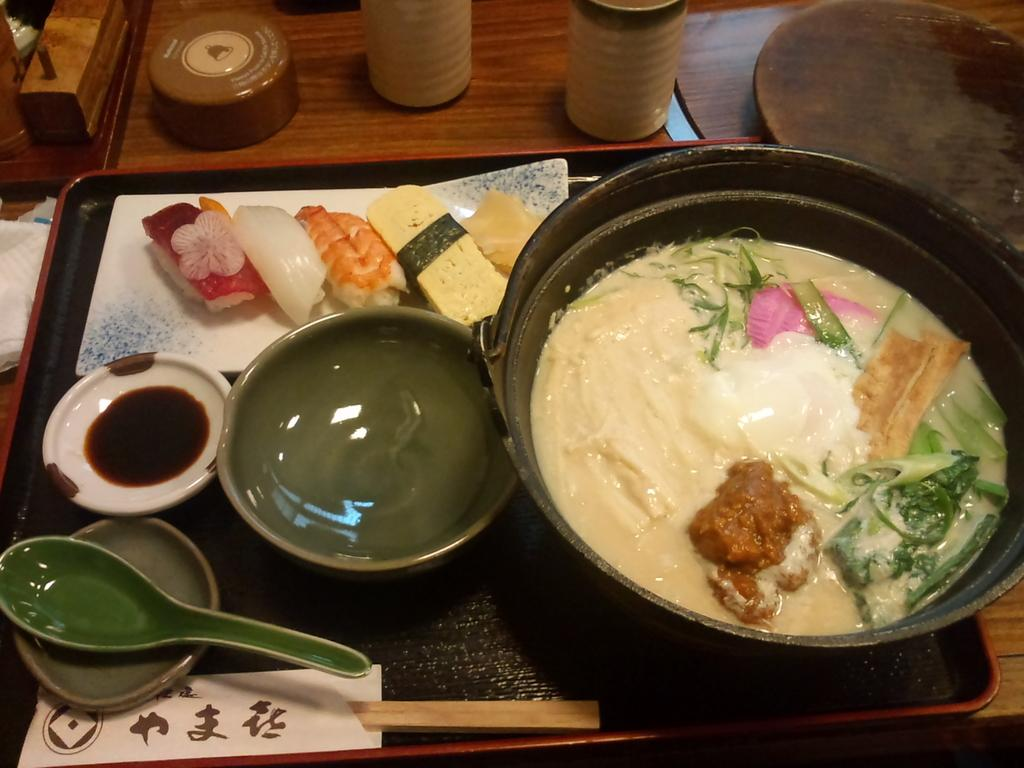What is the main piece of furniture in the image? There is a table in the image. What is placed on the table? On the table, there is a tray. What can be found inside the tray? The tray contains a bowl and food items. What utensil is present on the tray? There is a spoon on the tray. What other items are on the tray? There are sticks on the tray. What is located near the tray? There is a tissue paper aside the tray. What type of items are visible in the image? There are caps and a wooden item in the image. What type of war is being depicted in the image? There is no depiction of war in the image; it features a table with a tray, food items, and other objects. Is there a bed present in the image? No, there is no bed in the image; it features a table with a tray, food items, and other objects. 